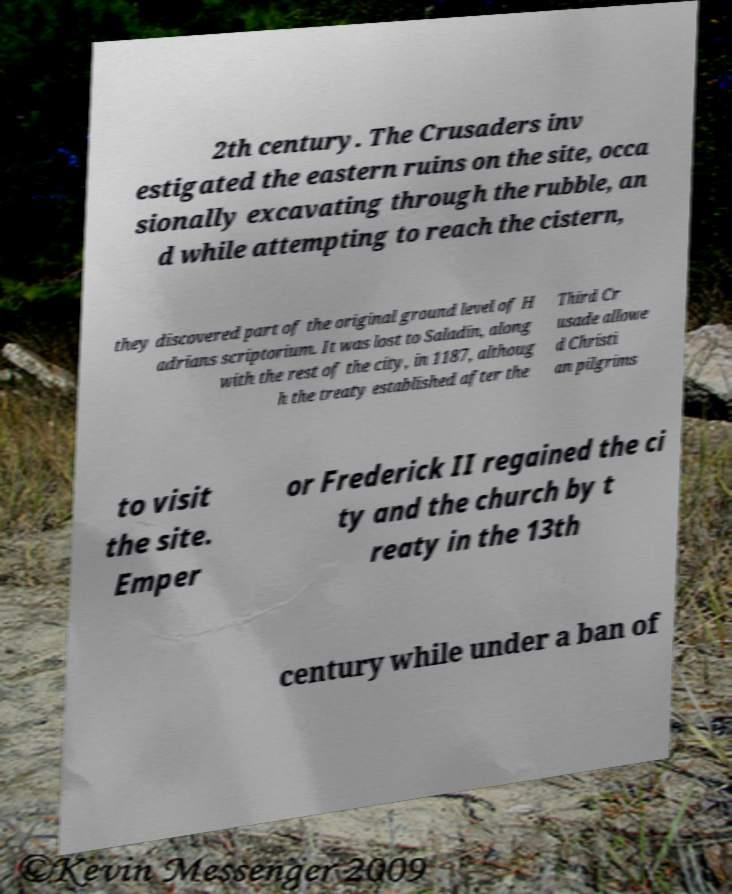Can you accurately transcribe the text from the provided image for me? 2th century. The Crusaders inv estigated the eastern ruins on the site, occa sionally excavating through the rubble, an d while attempting to reach the cistern, they discovered part of the original ground level of H adrians scriptorium. It was lost to Saladin, along with the rest of the city, in 1187, althoug h the treaty established after the Third Cr usade allowe d Christi an pilgrims to visit the site. Emper or Frederick II regained the ci ty and the church by t reaty in the 13th century while under a ban of 